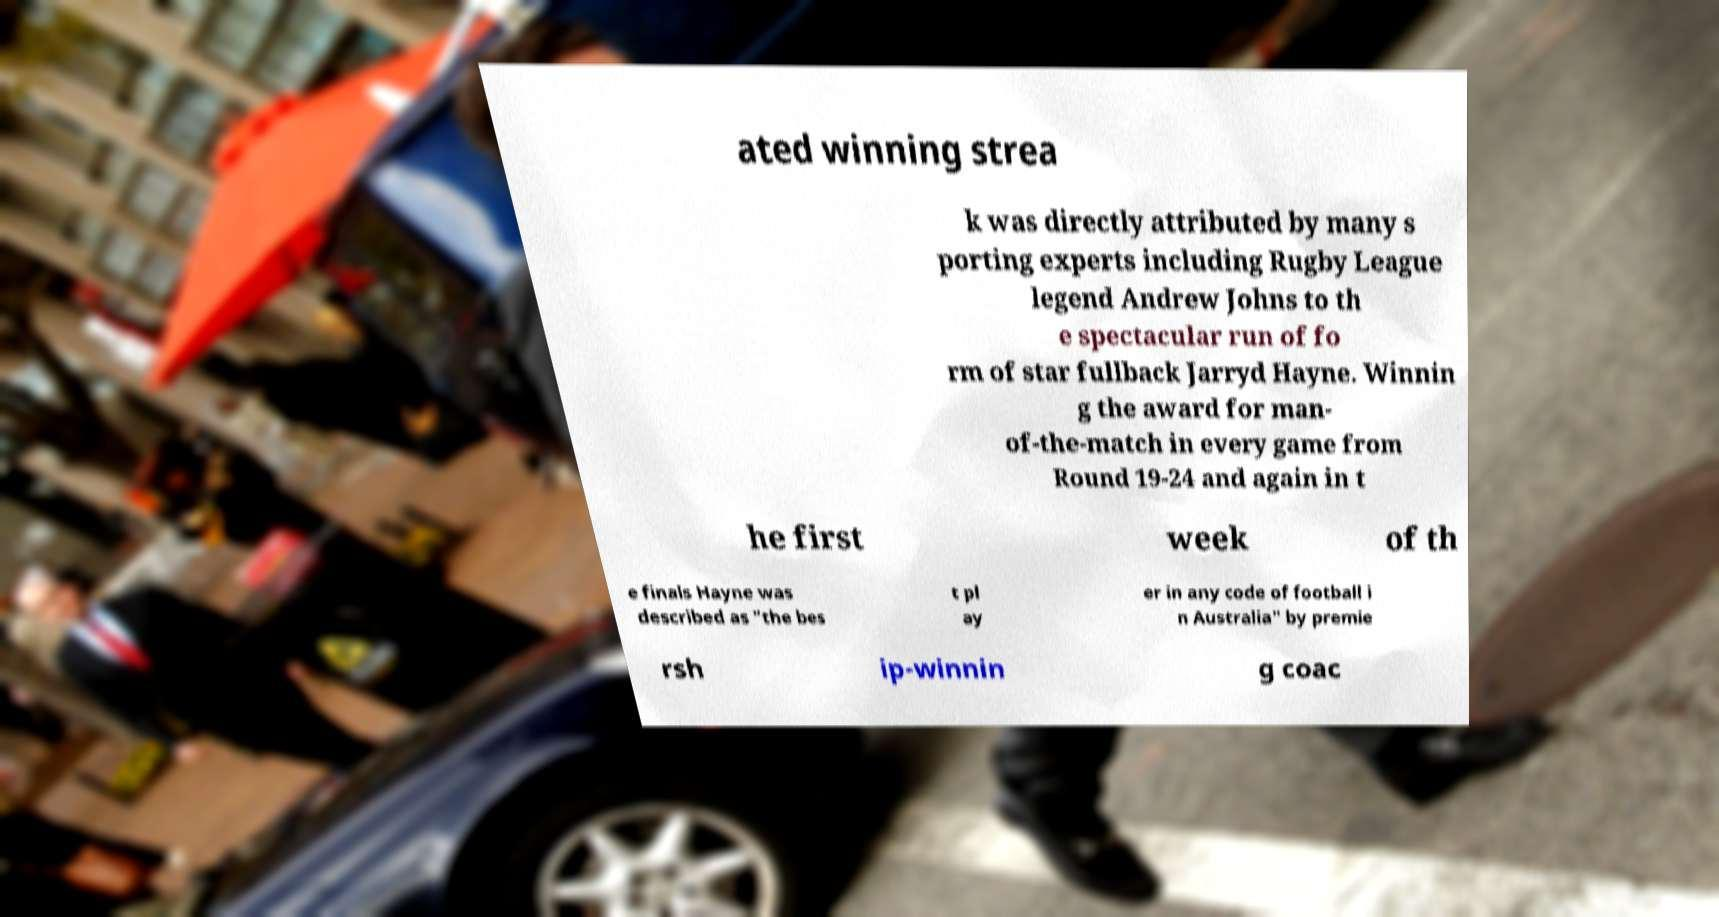What messages or text are displayed in this image? I need them in a readable, typed format. ated winning strea k was directly attributed by many s porting experts including Rugby League legend Andrew Johns to th e spectacular run of fo rm of star fullback Jarryd Hayne. Winnin g the award for man- of-the-match in every game from Round 19-24 and again in t he first week of th e finals Hayne was described as "the bes t pl ay er in any code of football i n Australia" by premie rsh ip-winnin g coac 